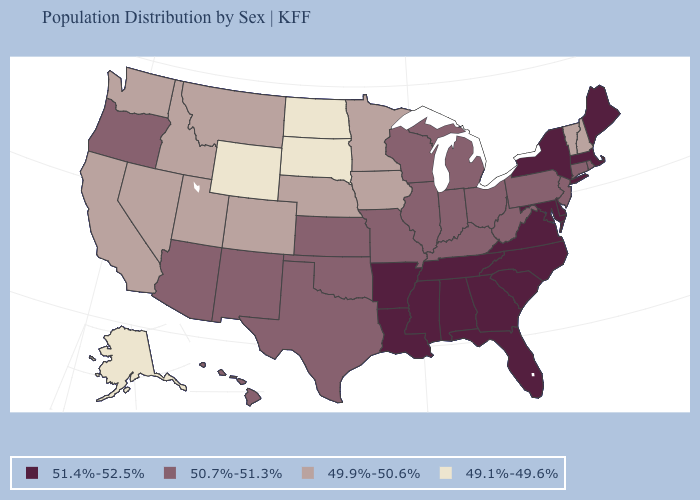What is the highest value in the MidWest ?
Concise answer only. 50.7%-51.3%. What is the value of Missouri?
Answer briefly. 50.7%-51.3%. Which states have the lowest value in the USA?
Give a very brief answer. Alaska, North Dakota, South Dakota, Wyoming. What is the value of North Dakota?
Concise answer only. 49.1%-49.6%. What is the value of South Dakota?
Short answer required. 49.1%-49.6%. What is the lowest value in the USA?
Answer briefly. 49.1%-49.6%. Does Virginia have the highest value in the USA?
Concise answer only. Yes. What is the value of South Dakota?
Concise answer only. 49.1%-49.6%. Does South Carolina have a higher value than Rhode Island?
Concise answer only. Yes. What is the value of Mississippi?
Quick response, please. 51.4%-52.5%. Name the states that have a value in the range 49.9%-50.6%?
Quick response, please. California, Colorado, Idaho, Iowa, Minnesota, Montana, Nebraska, Nevada, New Hampshire, Utah, Vermont, Washington. Does North Dakota have the lowest value in the USA?
Concise answer only. Yes. What is the lowest value in the Northeast?
Keep it brief. 49.9%-50.6%. What is the value of Massachusetts?
Quick response, please. 51.4%-52.5%. Does North Dakota have the lowest value in the USA?
Keep it brief. Yes. 